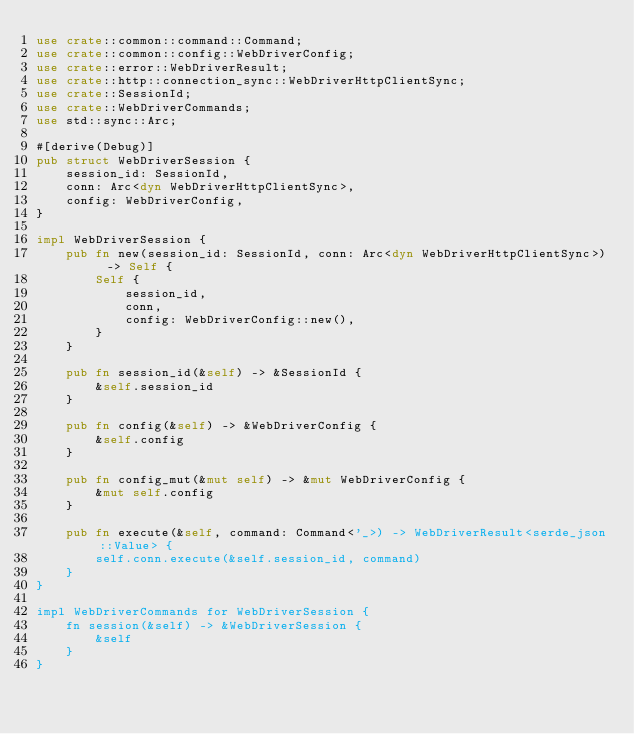<code> <loc_0><loc_0><loc_500><loc_500><_Rust_>use crate::common::command::Command;
use crate::common::config::WebDriverConfig;
use crate::error::WebDriverResult;
use crate::http::connection_sync::WebDriverHttpClientSync;
use crate::SessionId;
use crate::WebDriverCommands;
use std::sync::Arc;

#[derive(Debug)]
pub struct WebDriverSession {
    session_id: SessionId,
    conn: Arc<dyn WebDriverHttpClientSync>,
    config: WebDriverConfig,
}

impl WebDriverSession {
    pub fn new(session_id: SessionId, conn: Arc<dyn WebDriverHttpClientSync>) -> Self {
        Self {
            session_id,
            conn,
            config: WebDriverConfig::new(),
        }
    }

    pub fn session_id(&self) -> &SessionId {
        &self.session_id
    }

    pub fn config(&self) -> &WebDriverConfig {
        &self.config
    }

    pub fn config_mut(&mut self) -> &mut WebDriverConfig {
        &mut self.config
    }

    pub fn execute(&self, command: Command<'_>) -> WebDriverResult<serde_json::Value> {
        self.conn.execute(&self.session_id, command)
    }
}

impl WebDriverCommands for WebDriverSession {
    fn session(&self) -> &WebDriverSession {
        &self
    }
}
</code> 